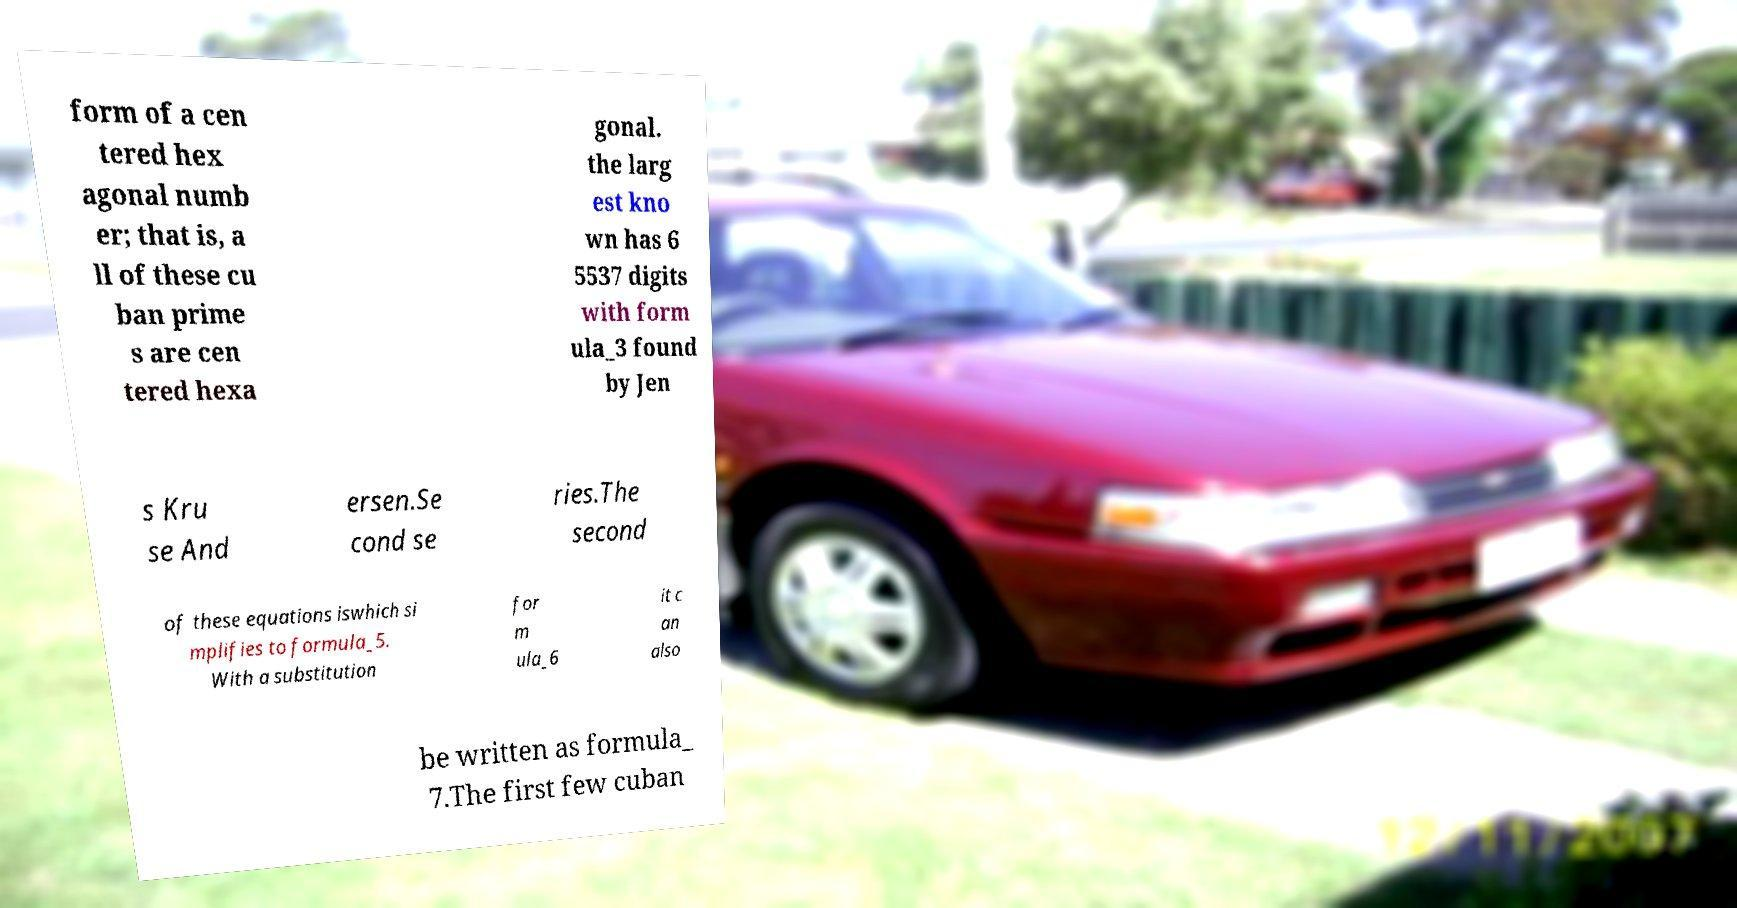Could you extract and type out the text from this image? form of a cen tered hex agonal numb er; that is, a ll of these cu ban prime s are cen tered hexa gonal. the larg est kno wn has 6 5537 digits with form ula_3 found by Jen s Kru se And ersen.Se cond se ries.The second of these equations iswhich si mplifies to formula_5. With a substitution for m ula_6 it c an also be written as formula_ 7.The first few cuban 